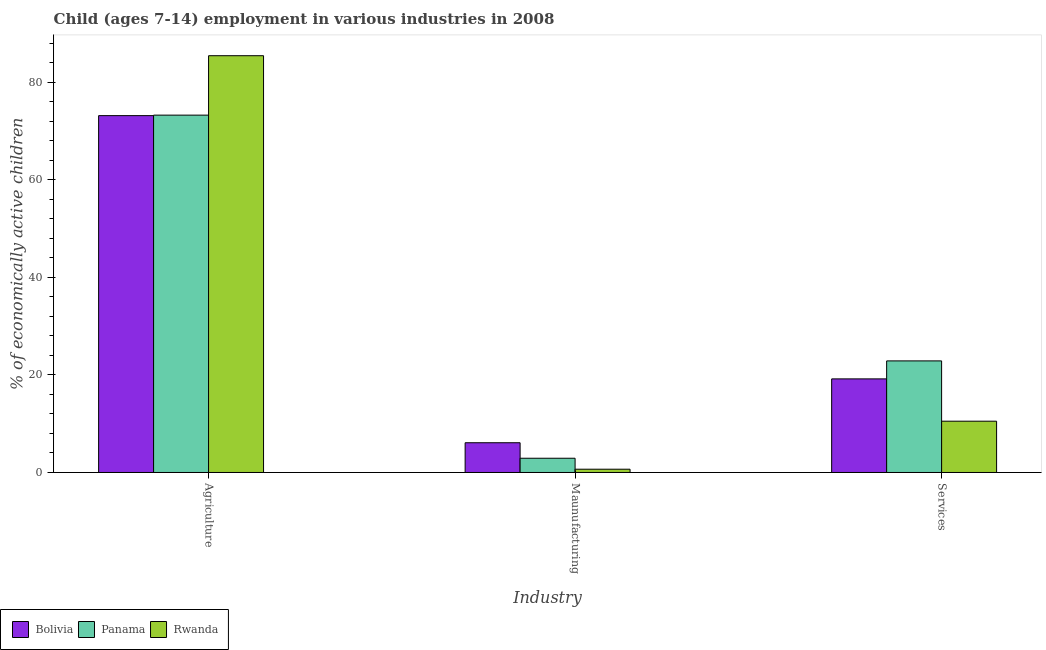Are the number of bars per tick equal to the number of legend labels?
Your response must be concise. Yes. How many bars are there on the 1st tick from the right?
Offer a terse response. 3. What is the label of the 1st group of bars from the left?
Provide a succinct answer. Agriculture. Across all countries, what is the maximum percentage of economically active children in manufacturing?
Your response must be concise. 6.1. Across all countries, what is the minimum percentage of economically active children in manufacturing?
Provide a succinct answer. 0.67. In which country was the percentage of economically active children in services maximum?
Your answer should be compact. Panama. In which country was the percentage of economically active children in agriculture minimum?
Your answer should be very brief. Bolivia. What is the total percentage of economically active children in manufacturing in the graph?
Offer a very short reply. 9.69. What is the difference between the percentage of economically active children in agriculture in Rwanda and that in Panama?
Keep it short and to the point. 12.19. What is the difference between the percentage of economically active children in agriculture in Panama and the percentage of economically active children in manufacturing in Rwanda?
Provide a short and direct response. 72.63. What is the average percentage of economically active children in services per country?
Provide a short and direct response. 17.54. What is the difference between the percentage of economically active children in manufacturing and percentage of economically active children in agriculture in Bolivia?
Give a very brief answer. -67.1. In how many countries, is the percentage of economically active children in services greater than 36 %?
Ensure brevity in your answer.  0. What is the ratio of the percentage of economically active children in agriculture in Bolivia to that in Rwanda?
Offer a very short reply. 0.86. Is the percentage of economically active children in agriculture in Bolivia less than that in Panama?
Provide a short and direct response. Yes. Is the difference between the percentage of economically active children in agriculture in Bolivia and Panama greater than the difference between the percentage of economically active children in services in Bolivia and Panama?
Keep it short and to the point. Yes. What is the difference between the highest and the second highest percentage of economically active children in agriculture?
Provide a succinct answer. 12.19. What is the difference between the highest and the lowest percentage of economically active children in manufacturing?
Give a very brief answer. 5.43. Is the sum of the percentage of economically active children in manufacturing in Panama and Bolivia greater than the maximum percentage of economically active children in services across all countries?
Your answer should be very brief. No. What does the 3rd bar from the left in Services represents?
Keep it short and to the point. Rwanda. What does the 1st bar from the right in Agriculture represents?
Offer a very short reply. Rwanda. How many bars are there?
Give a very brief answer. 9. Are all the bars in the graph horizontal?
Provide a short and direct response. No. What is the difference between two consecutive major ticks on the Y-axis?
Offer a very short reply. 20. Are the values on the major ticks of Y-axis written in scientific E-notation?
Ensure brevity in your answer.  No. Does the graph contain any zero values?
Provide a short and direct response. No. What is the title of the graph?
Ensure brevity in your answer.  Child (ages 7-14) employment in various industries in 2008. Does "Belgium" appear as one of the legend labels in the graph?
Give a very brief answer. No. What is the label or title of the X-axis?
Give a very brief answer. Industry. What is the label or title of the Y-axis?
Keep it short and to the point. % of economically active children. What is the % of economically active children of Bolivia in Agriculture?
Your response must be concise. 73.2. What is the % of economically active children in Panama in Agriculture?
Keep it short and to the point. 73.3. What is the % of economically active children in Rwanda in Agriculture?
Give a very brief answer. 85.49. What is the % of economically active children of Bolivia in Maunufacturing?
Offer a very short reply. 6.1. What is the % of economically active children of Panama in Maunufacturing?
Keep it short and to the point. 2.92. What is the % of economically active children of Rwanda in Maunufacturing?
Offer a very short reply. 0.67. What is the % of economically active children of Bolivia in Services?
Offer a very short reply. 19.2. What is the % of economically active children of Panama in Services?
Your response must be concise. 22.89. What is the % of economically active children of Rwanda in Services?
Keep it short and to the point. 10.52. Across all Industry, what is the maximum % of economically active children of Bolivia?
Provide a short and direct response. 73.2. Across all Industry, what is the maximum % of economically active children in Panama?
Provide a short and direct response. 73.3. Across all Industry, what is the maximum % of economically active children of Rwanda?
Provide a succinct answer. 85.49. Across all Industry, what is the minimum % of economically active children of Bolivia?
Offer a terse response. 6.1. Across all Industry, what is the minimum % of economically active children of Panama?
Your answer should be very brief. 2.92. Across all Industry, what is the minimum % of economically active children of Rwanda?
Ensure brevity in your answer.  0.67. What is the total % of economically active children of Bolivia in the graph?
Your answer should be very brief. 98.5. What is the total % of economically active children in Panama in the graph?
Provide a short and direct response. 99.11. What is the total % of economically active children of Rwanda in the graph?
Keep it short and to the point. 96.68. What is the difference between the % of economically active children in Bolivia in Agriculture and that in Maunufacturing?
Provide a short and direct response. 67.1. What is the difference between the % of economically active children in Panama in Agriculture and that in Maunufacturing?
Provide a succinct answer. 70.38. What is the difference between the % of economically active children in Rwanda in Agriculture and that in Maunufacturing?
Offer a very short reply. 84.82. What is the difference between the % of economically active children of Bolivia in Agriculture and that in Services?
Your answer should be very brief. 54. What is the difference between the % of economically active children in Panama in Agriculture and that in Services?
Offer a terse response. 50.41. What is the difference between the % of economically active children in Rwanda in Agriculture and that in Services?
Offer a terse response. 74.97. What is the difference between the % of economically active children of Bolivia in Maunufacturing and that in Services?
Provide a succinct answer. -13.1. What is the difference between the % of economically active children in Panama in Maunufacturing and that in Services?
Offer a very short reply. -19.97. What is the difference between the % of economically active children in Rwanda in Maunufacturing and that in Services?
Your response must be concise. -9.85. What is the difference between the % of economically active children in Bolivia in Agriculture and the % of economically active children in Panama in Maunufacturing?
Ensure brevity in your answer.  70.28. What is the difference between the % of economically active children in Bolivia in Agriculture and the % of economically active children in Rwanda in Maunufacturing?
Offer a terse response. 72.53. What is the difference between the % of economically active children of Panama in Agriculture and the % of economically active children of Rwanda in Maunufacturing?
Your answer should be very brief. 72.63. What is the difference between the % of economically active children of Bolivia in Agriculture and the % of economically active children of Panama in Services?
Offer a terse response. 50.31. What is the difference between the % of economically active children in Bolivia in Agriculture and the % of economically active children in Rwanda in Services?
Your answer should be compact. 62.68. What is the difference between the % of economically active children in Panama in Agriculture and the % of economically active children in Rwanda in Services?
Provide a succinct answer. 62.78. What is the difference between the % of economically active children in Bolivia in Maunufacturing and the % of economically active children in Panama in Services?
Keep it short and to the point. -16.79. What is the difference between the % of economically active children in Bolivia in Maunufacturing and the % of economically active children in Rwanda in Services?
Your answer should be very brief. -4.42. What is the average % of economically active children of Bolivia per Industry?
Give a very brief answer. 32.83. What is the average % of economically active children in Panama per Industry?
Your answer should be very brief. 33.04. What is the average % of economically active children in Rwanda per Industry?
Offer a terse response. 32.23. What is the difference between the % of economically active children of Bolivia and % of economically active children of Panama in Agriculture?
Your answer should be very brief. -0.1. What is the difference between the % of economically active children of Bolivia and % of economically active children of Rwanda in Agriculture?
Offer a very short reply. -12.29. What is the difference between the % of economically active children of Panama and % of economically active children of Rwanda in Agriculture?
Give a very brief answer. -12.19. What is the difference between the % of economically active children of Bolivia and % of economically active children of Panama in Maunufacturing?
Your answer should be compact. 3.18. What is the difference between the % of economically active children in Bolivia and % of economically active children in Rwanda in Maunufacturing?
Provide a short and direct response. 5.43. What is the difference between the % of economically active children of Panama and % of economically active children of Rwanda in Maunufacturing?
Offer a terse response. 2.25. What is the difference between the % of economically active children in Bolivia and % of economically active children in Panama in Services?
Make the answer very short. -3.69. What is the difference between the % of economically active children of Bolivia and % of economically active children of Rwanda in Services?
Offer a terse response. 8.68. What is the difference between the % of economically active children in Panama and % of economically active children in Rwanda in Services?
Make the answer very short. 12.37. What is the ratio of the % of economically active children of Bolivia in Agriculture to that in Maunufacturing?
Ensure brevity in your answer.  12. What is the ratio of the % of economically active children in Panama in Agriculture to that in Maunufacturing?
Ensure brevity in your answer.  25.1. What is the ratio of the % of economically active children in Rwanda in Agriculture to that in Maunufacturing?
Keep it short and to the point. 127.6. What is the ratio of the % of economically active children of Bolivia in Agriculture to that in Services?
Offer a terse response. 3.81. What is the ratio of the % of economically active children in Panama in Agriculture to that in Services?
Your answer should be compact. 3.2. What is the ratio of the % of economically active children in Rwanda in Agriculture to that in Services?
Keep it short and to the point. 8.13. What is the ratio of the % of economically active children in Bolivia in Maunufacturing to that in Services?
Ensure brevity in your answer.  0.32. What is the ratio of the % of economically active children of Panama in Maunufacturing to that in Services?
Ensure brevity in your answer.  0.13. What is the ratio of the % of economically active children in Rwanda in Maunufacturing to that in Services?
Give a very brief answer. 0.06. What is the difference between the highest and the second highest % of economically active children in Bolivia?
Provide a succinct answer. 54. What is the difference between the highest and the second highest % of economically active children of Panama?
Your answer should be very brief. 50.41. What is the difference between the highest and the second highest % of economically active children in Rwanda?
Provide a succinct answer. 74.97. What is the difference between the highest and the lowest % of economically active children in Bolivia?
Keep it short and to the point. 67.1. What is the difference between the highest and the lowest % of economically active children in Panama?
Provide a succinct answer. 70.38. What is the difference between the highest and the lowest % of economically active children of Rwanda?
Ensure brevity in your answer.  84.82. 